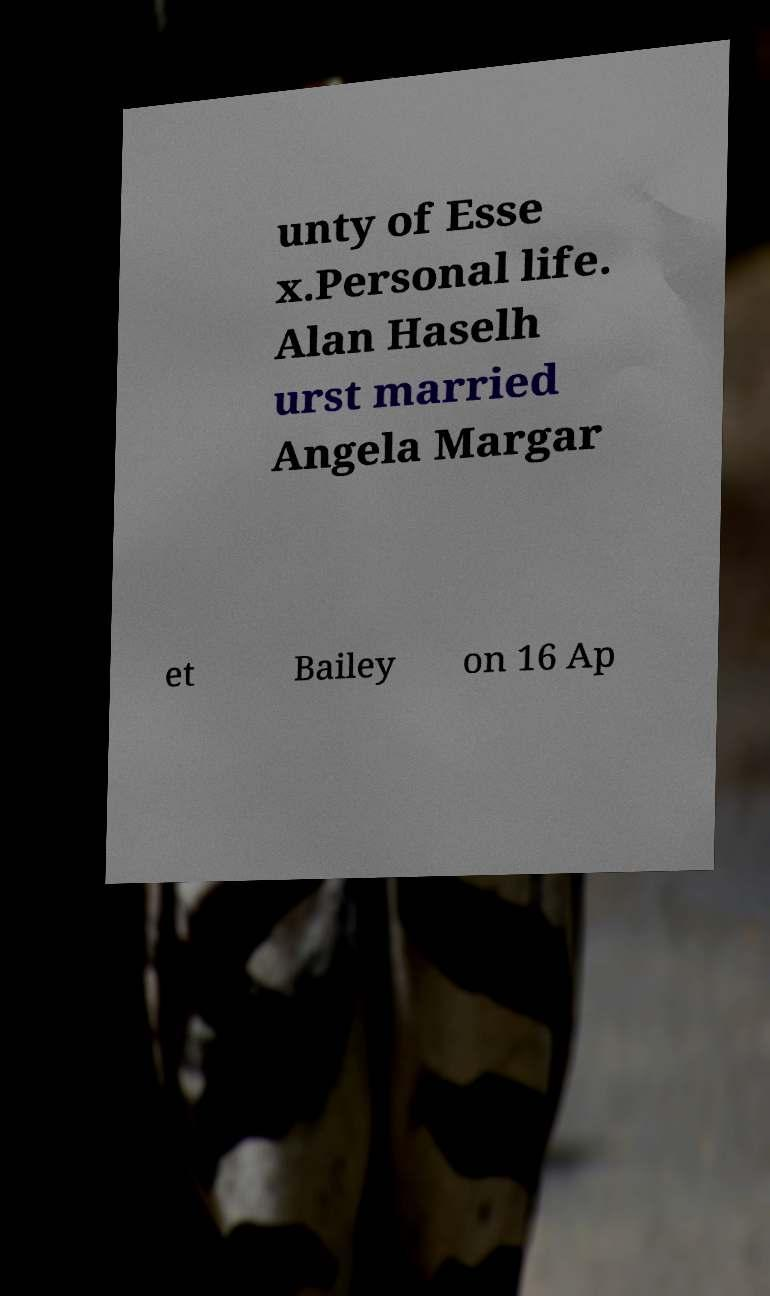Can you read and provide the text displayed in the image?This photo seems to have some interesting text. Can you extract and type it out for me? unty of Esse x.Personal life. Alan Haselh urst married Angela Margar et Bailey on 16 Ap 